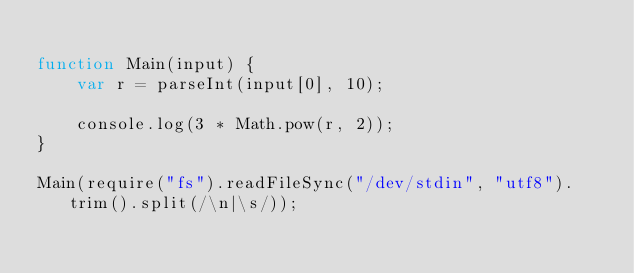<code> <loc_0><loc_0><loc_500><loc_500><_JavaScript_>
function Main(input) {
    var r = parseInt(input[0], 10);

    console.log(3 * Math.pow(r, 2));
}

Main(require("fs").readFileSync("/dev/stdin", "utf8").trim().split(/\n|\s/));</code> 